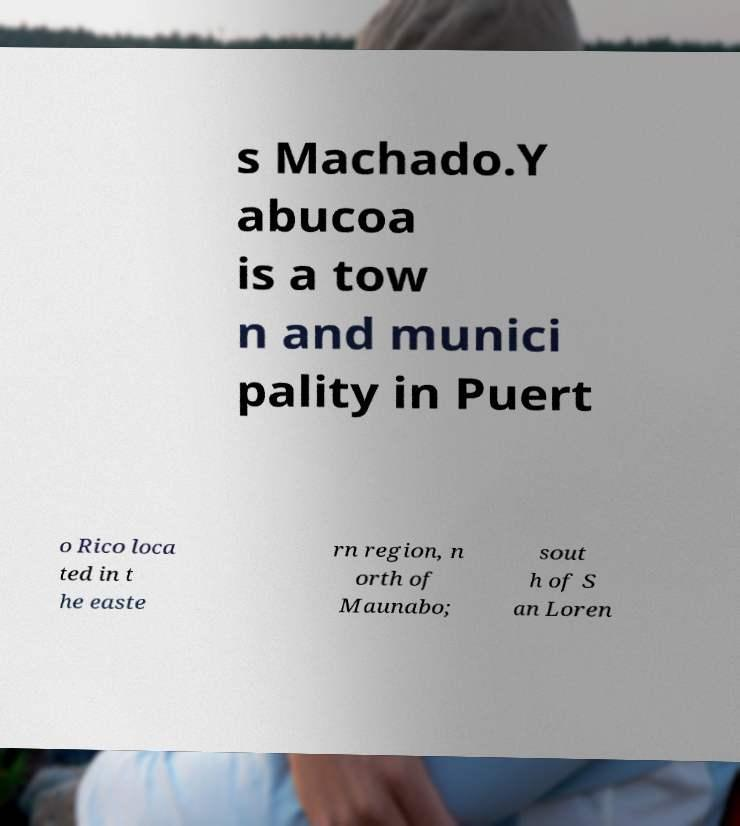Could you extract and type out the text from this image? s Machado.Y abucoa is a tow n and munici pality in Puert o Rico loca ted in t he easte rn region, n orth of Maunabo; sout h of S an Loren 